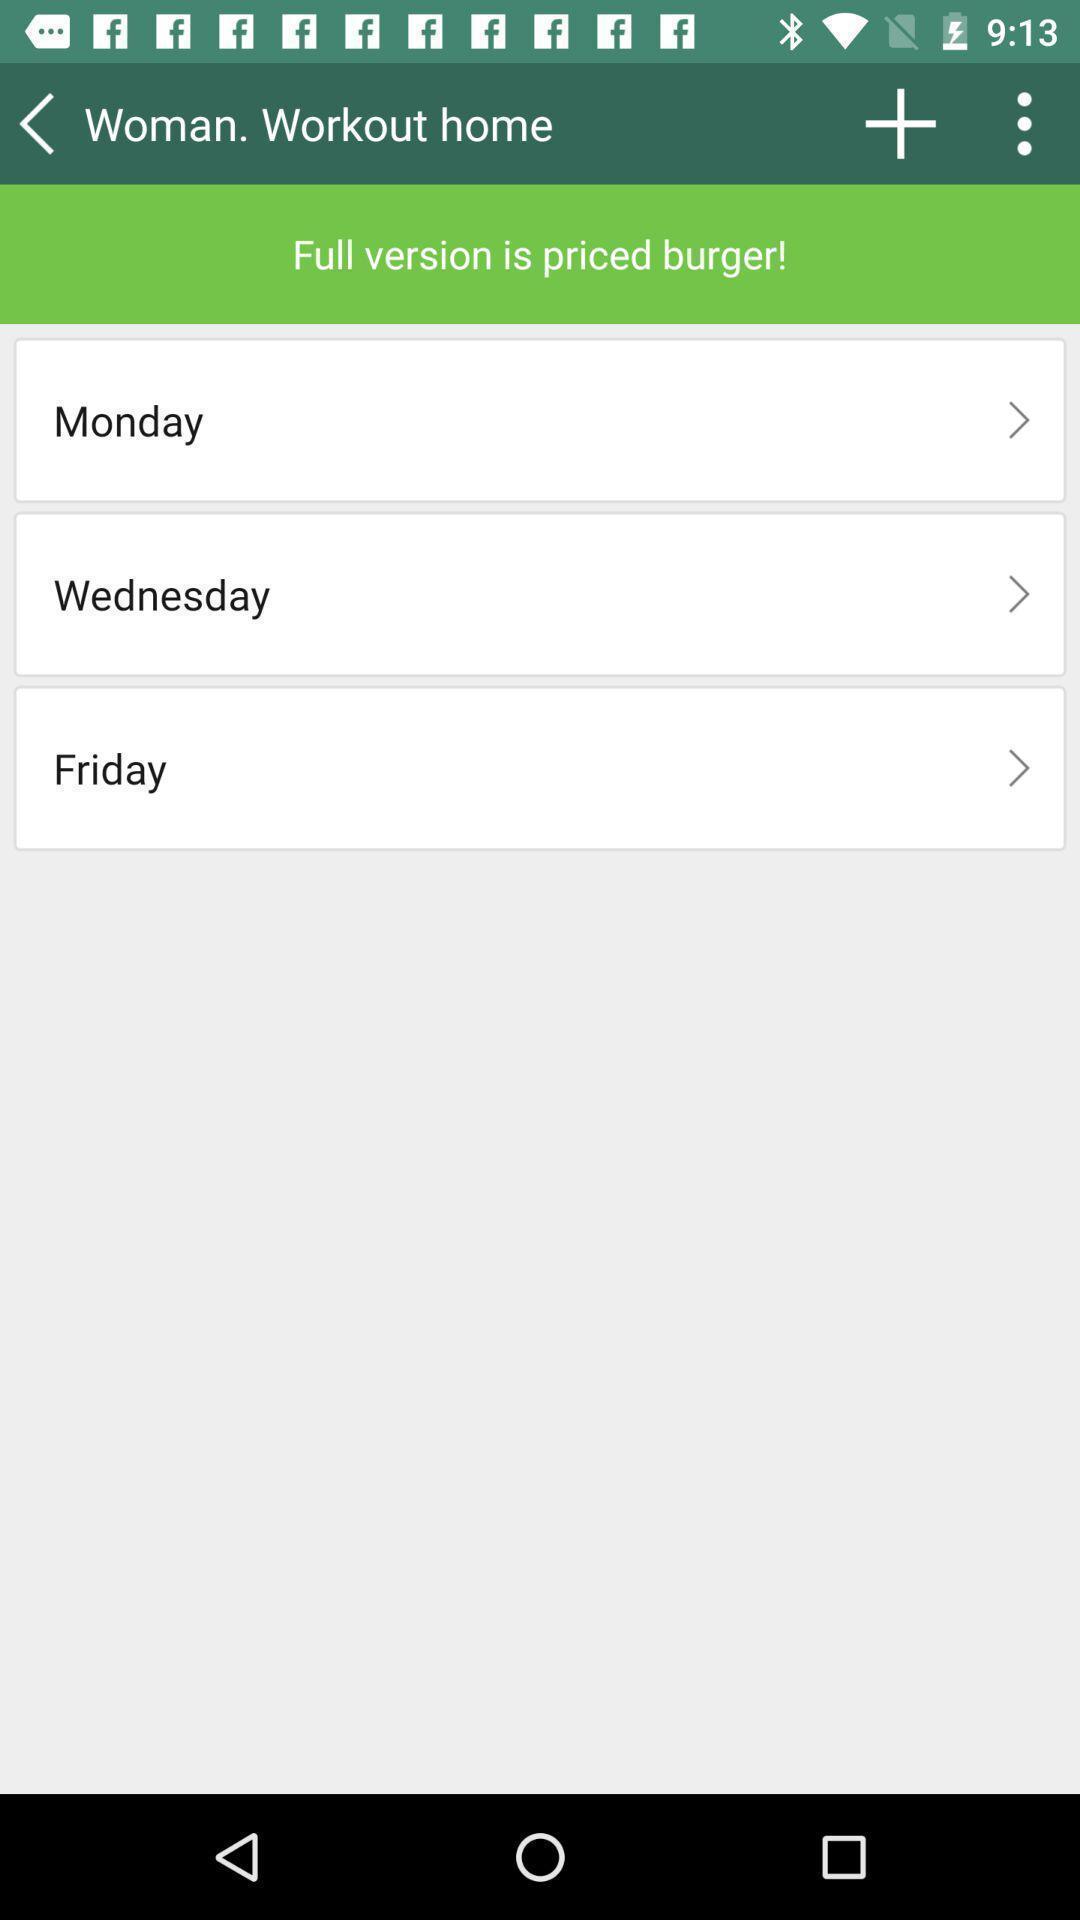Please provide a description for this image. Screen displaying the list of days in a fitness app. 